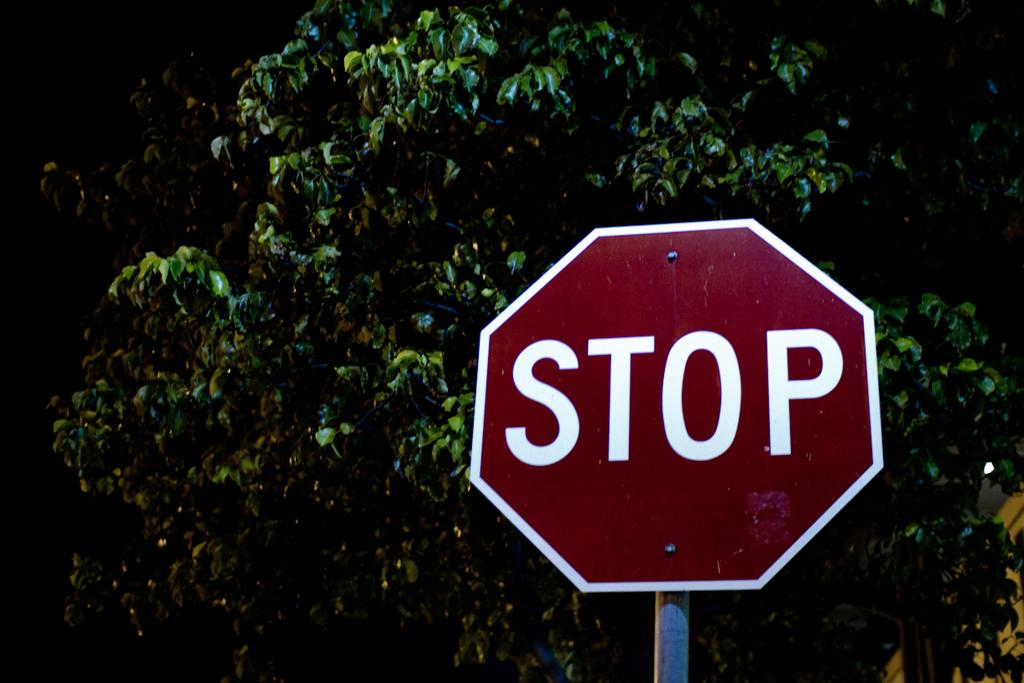<image>
Summarize the visual content of the image. A red stop sign that is in front of trees. 